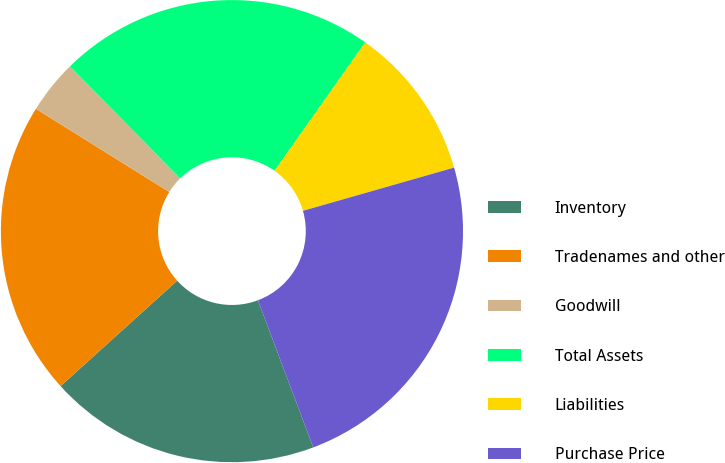Convert chart to OTSL. <chart><loc_0><loc_0><loc_500><loc_500><pie_chart><fcel>Inventory<fcel>Tradenames and other<fcel>Goodwill<fcel>Total Assets<fcel>Liabilities<fcel>Purchase Price<nl><fcel>19.02%<fcel>20.58%<fcel>3.76%<fcel>22.15%<fcel>10.78%<fcel>23.71%<nl></chart> 